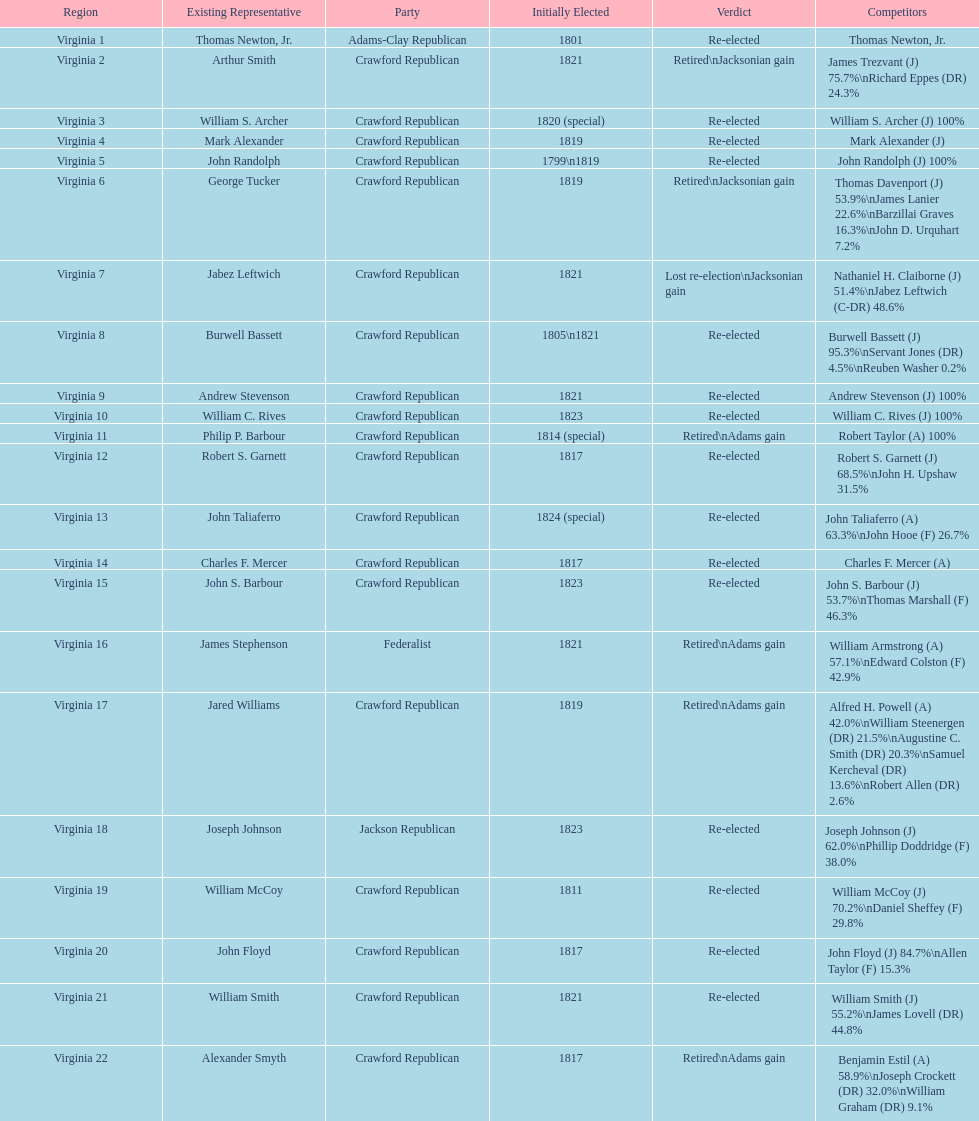Who was the next incumbent after john randolph? George Tucker. 